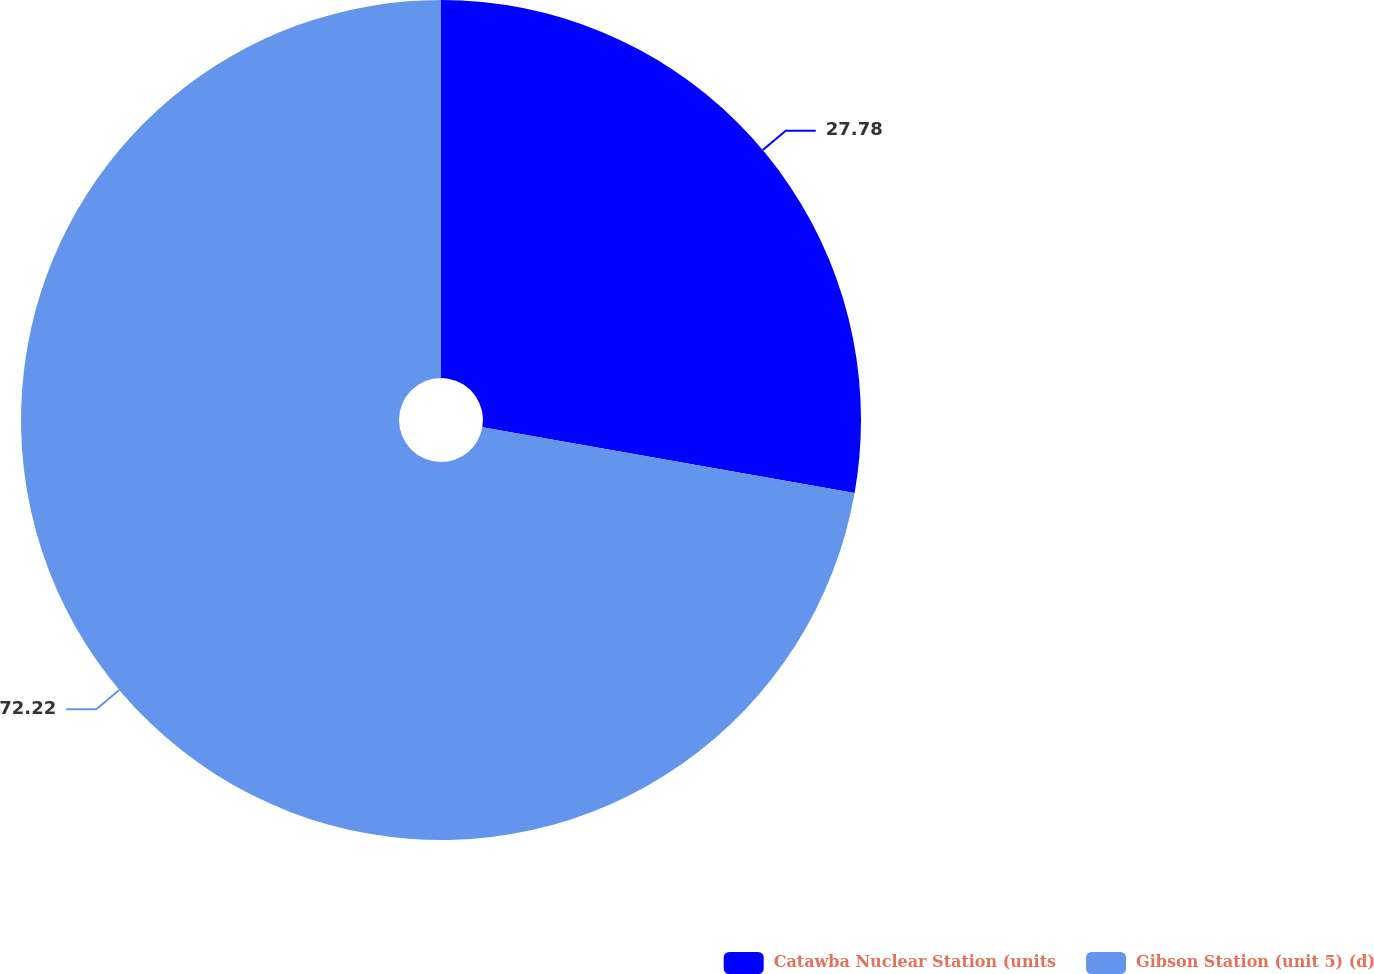<chart> <loc_0><loc_0><loc_500><loc_500><pie_chart><fcel>Catawba Nuclear Station (units<fcel>Gibson Station (unit 5) (d)<nl><fcel>27.78%<fcel>72.22%<nl></chart> 